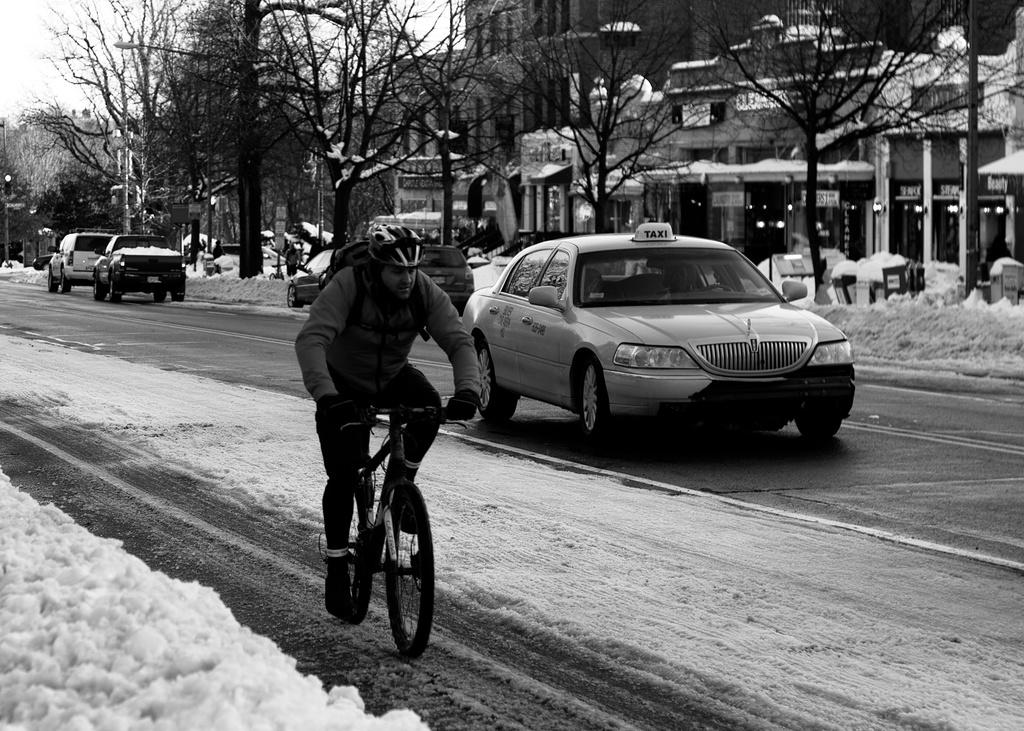What can be seen in the background of the image? There is a sky in the image. What type of vegetation is present in the image? There are dry trees in the image. What type of structures are visible in the image? There are buildings in the image. What type of transportation is present on the road in the image? There are cars on the road in the image. What is the man in the front of the image doing? A man is riding a bicycle in the front in the image. What type of arm is visible in the image? There is no arm visible in the image. What substance is being brushed with a toothbrush in the image? There is no toothbrush or substance being brushed in the image. 